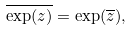Convert formula to latex. <formula><loc_0><loc_0><loc_500><loc_500>\overline { \exp ( z ) } = \exp ( \overline { z } ) ,</formula> 